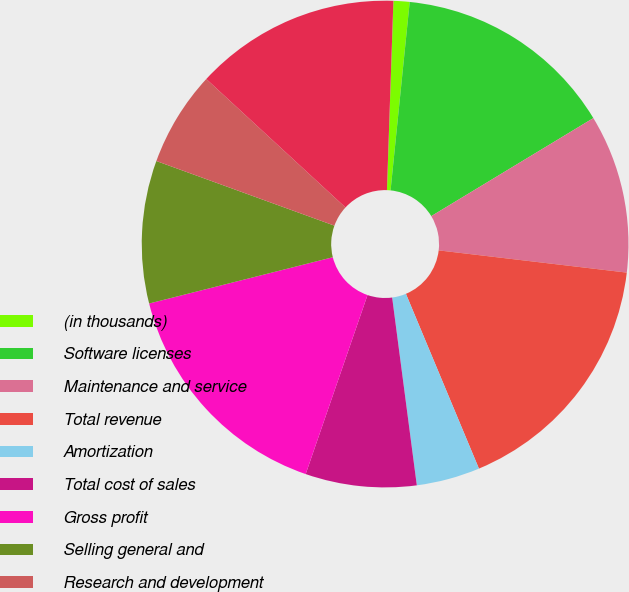Convert chart to OTSL. <chart><loc_0><loc_0><loc_500><loc_500><pie_chart><fcel>(in thousands)<fcel>Software licenses<fcel>Maintenance and service<fcel>Total revenue<fcel>Amortization<fcel>Total cost of sales<fcel>Gross profit<fcel>Selling general and<fcel>Research and development<fcel>Total operating expenses<nl><fcel>1.07%<fcel>14.73%<fcel>10.53%<fcel>16.83%<fcel>4.22%<fcel>7.37%<fcel>15.78%<fcel>9.47%<fcel>6.32%<fcel>13.68%<nl></chart> 